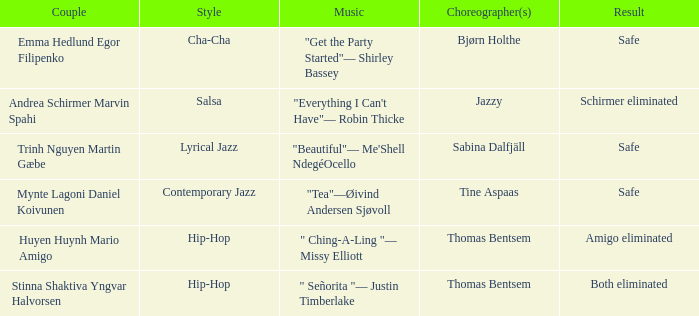What is the result of choreographer bjørn holthe? Safe. 